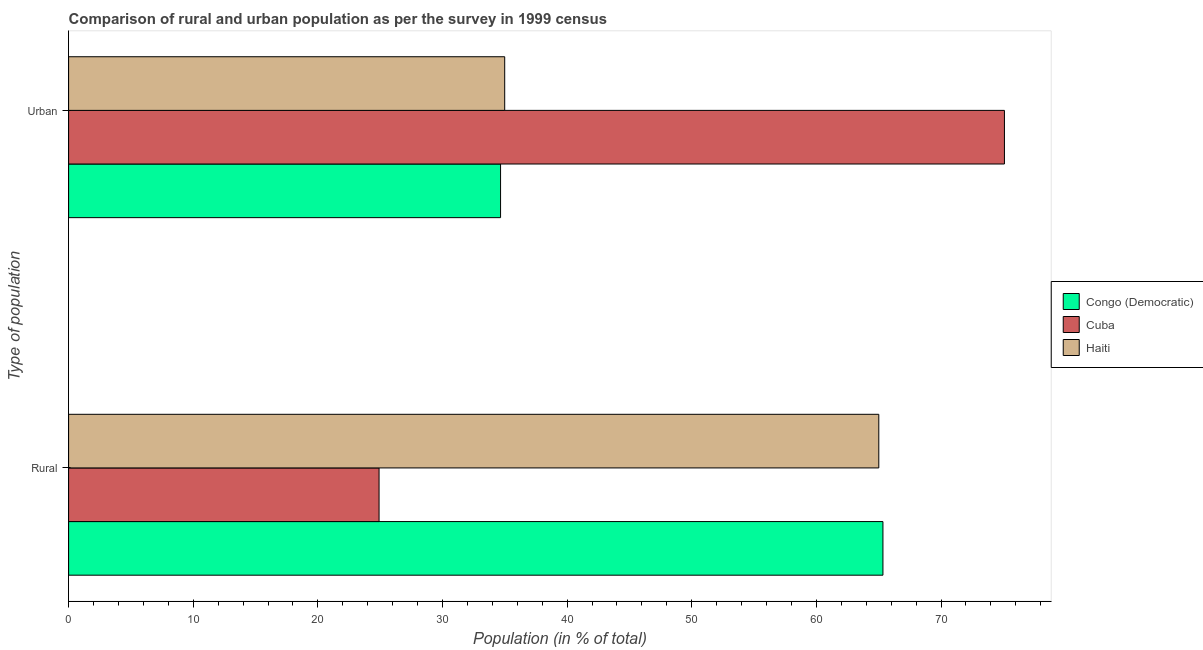How many different coloured bars are there?
Your response must be concise. 3. How many groups of bars are there?
Ensure brevity in your answer.  2. Are the number of bars per tick equal to the number of legend labels?
Offer a very short reply. Yes. Are the number of bars on each tick of the Y-axis equal?
Your response must be concise. Yes. How many bars are there on the 2nd tick from the top?
Keep it short and to the point. 3. What is the label of the 1st group of bars from the top?
Keep it short and to the point. Urban. What is the rural population in Cuba?
Provide a short and direct response. 24.91. Across all countries, what is the maximum rural population?
Keep it short and to the point. 65.34. Across all countries, what is the minimum urban population?
Your response must be concise. 34.66. In which country was the urban population maximum?
Ensure brevity in your answer.  Cuba. In which country was the rural population minimum?
Your response must be concise. Cuba. What is the total urban population in the graph?
Offer a very short reply. 144.74. What is the difference between the urban population in Cuba and that in Haiti?
Provide a succinct answer. 40.1. What is the difference between the rural population in Cuba and the urban population in Congo (Democratic)?
Your response must be concise. -9.75. What is the average urban population per country?
Your response must be concise. 48.25. What is the difference between the urban population and rural population in Congo (Democratic)?
Provide a short and direct response. -30.68. What is the ratio of the rural population in Haiti to that in Cuba?
Your answer should be compact. 2.61. What does the 2nd bar from the top in Rural represents?
Give a very brief answer. Cuba. What does the 2nd bar from the bottom in Urban represents?
Your response must be concise. Cuba. How many bars are there?
Provide a succinct answer. 6. Are all the bars in the graph horizontal?
Your answer should be very brief. Yes. Are the values on the major ticks of X-axis written in scientific E-notation?
Your answer should be very brief. No. Where does the legend appear in the graph?
Offer a terse response. Center right. What is the title of the graph?
Offer a terse response. Comparison of rural and urban population as per the survey in 1999 census. What is the label or title of the X-axis?
Make the answer very short. Population (in % of total). What is the label or title of the Y-axis?
Offer a terse response. Type of population. What is the Population (in % of total) of Congo (Democratic) in Rural?
Make the answer very short. 65.34. What is the Population (in % of total) of Cuba in Rural?
Ensure brevity in your answer.  24.91. What is the Population (in % of total) of Haiti in Rural?
Keep it short and to the point. 65.01. What is the Population (in % of total) in Congo (Democratic) in Urban?
Your response must be concise. 34.66. What is the Population (in % of total) in Cuba in Urban?
Provide a succinct answer. 75.09. What is the Population (in % of total) in Haiti in Urban?
Offer a very short reply. 34.99. Across all Type of population, what is the maximum Population (in % of total) in Congo (Democratic)?
Ensure brevity in your answer.  65.34. Across all Type of population, what is the maximum Population (in % of total) in Cuba?
Offer a terse response. 75.09. Across all Type of population, what is the maximum Population (in % of total) in Haiti?
Your response must be concise. 65.01. Across all Type of population, what is the minimum Population (in % of total) of Congo (Democratic)?
Keep it short and to the point. 34.66. Across all Type of population, what is the minimum Population (in % of total) of Cuba?
Ensure brevity in your answer.  24.91. Across all Type of population, what is the minimum Population (in % of total) in Haiti?
Make the answer very short. 34.99. What is the total Population (in % of total) of Congo (Democratic) in the graph?
Give a very brief answer. 100. What is the total Population (in % of total) of Cuba in the graph?
Provide a short and direct response. 100. What is the total Population (in % of total) in Haiti in the graph?
Offer a very short reply. 100. What is the difference between the Population (in % of total) of Congo (Democratic) in Rural and that in Urban?
Offer a very short reply. 30.68. What is the difference between the Population (in % of total) in Cuba in Rural and that in Urban?
Keep it short and to the point. -50.18. What is the difference between the Population (in % of total) in Haiti in Rural and that in Urban?
Your response must be concise. 30.02. What is the difference between the Population (in % of total) of Congo (Democratic) in Rural and the Population (in % of total) of Cuba in Urban?
Give a very brief answer. -9.75. What is the difference between the Population (in % of total) of Congo (Democratic) in Rural and the Population (in % of total) of Haiti in Urban?
Ensure brevity in your answer.  30.35. What is the difference between the Population (in % of total) in Cuba in Rural and the Population (in % of total) in Haiti in Urban?
Give a very brief answer. -10.08. What is the average Population (in % of total) of Cuba per Type of population?
Offer a very short reply. 50. What is the average Population (in % of total) of Haiti per Type of population?
Provide a succinct answer. 50. What is the difference between the Population (in % of total) of Congo (Democratic) and Population (in % of total) of Cuba in Rural?
Keep it short and to the point. 40.43. What is the difference between the Population (in % of total) in Congo (Democratic) and Population (in % of total) in Haiti in Rural?
Provide a succinct answer. 0.33. What is the difference between the Population (in % of total) of Cuba and Population (in % of total) of Haiti in Rural?
Keep it short and to the point. -40.1. What is the difference between the Population (in % of total) in Congo (Democratic) and Population (in % of total) in Cuba in Urban?
Provide a short and direct response. -40.43. What is the difference between the Population (in % of total) in Congo (Democratic) and Population (in % of total) in Haiti in Urban?
Your answer should be compact. -0.33. What is the difference between the Population (in % of total) in Cuba and Population (in % of total) in Haiti in Urban?
Give a very brief answer. 40.1. What is the ratio of the Population (in % of total) in Congo (Democratic) in Rural to that in Urban?
Your response must be concise. 1.89. What is the ratio of the Population (in % of total) of Cuba in Rural to that in Urban?
Your answer should be very brief. 0.33. What is the ratio of the Population (in % of total) of Haiti in Rural to that in Urban?
Offer a very short reply. 1.86. What is the difference between the highest and the second highest Population (in % of total) in Congo (Democratic)?
Your response must be concise. 30.68. What is the difference between the highest and the second highest Population (in % of total) of Cuba?
Your answer should be compact. 50.18. What is the difference between the highest and the second highest Population (in % of total) in Haiti?
Your answer should be very brief. 30.02. What is the difference between the highest and the lowest Population (in % of total) in Congo (Democratic)?
Your answer should be very brief. 30.68. What is the difference between the highest and the lowest Population (in % of total) in Cuba?
Your response must be concise. 50.18. What is the difference between the highest and the lowest Population (in % of total) of Haiti?
Your answer should be compact. 30.02. 